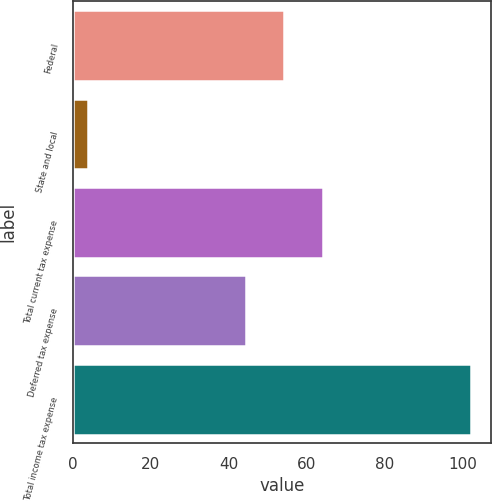Convert chart. <chart><loc_0><loc_0><loc_500><loc_500><bar_chart><fcel>Federal<fcel>State and local<fcel>Total current tax expense<fcel>Deferred tax expense<fcel>Total income tax expense<nl><fcel>54.23<fcel>3.9<fcel>64.06<fcel>44.4<fcel>102.2<nl></chart> 